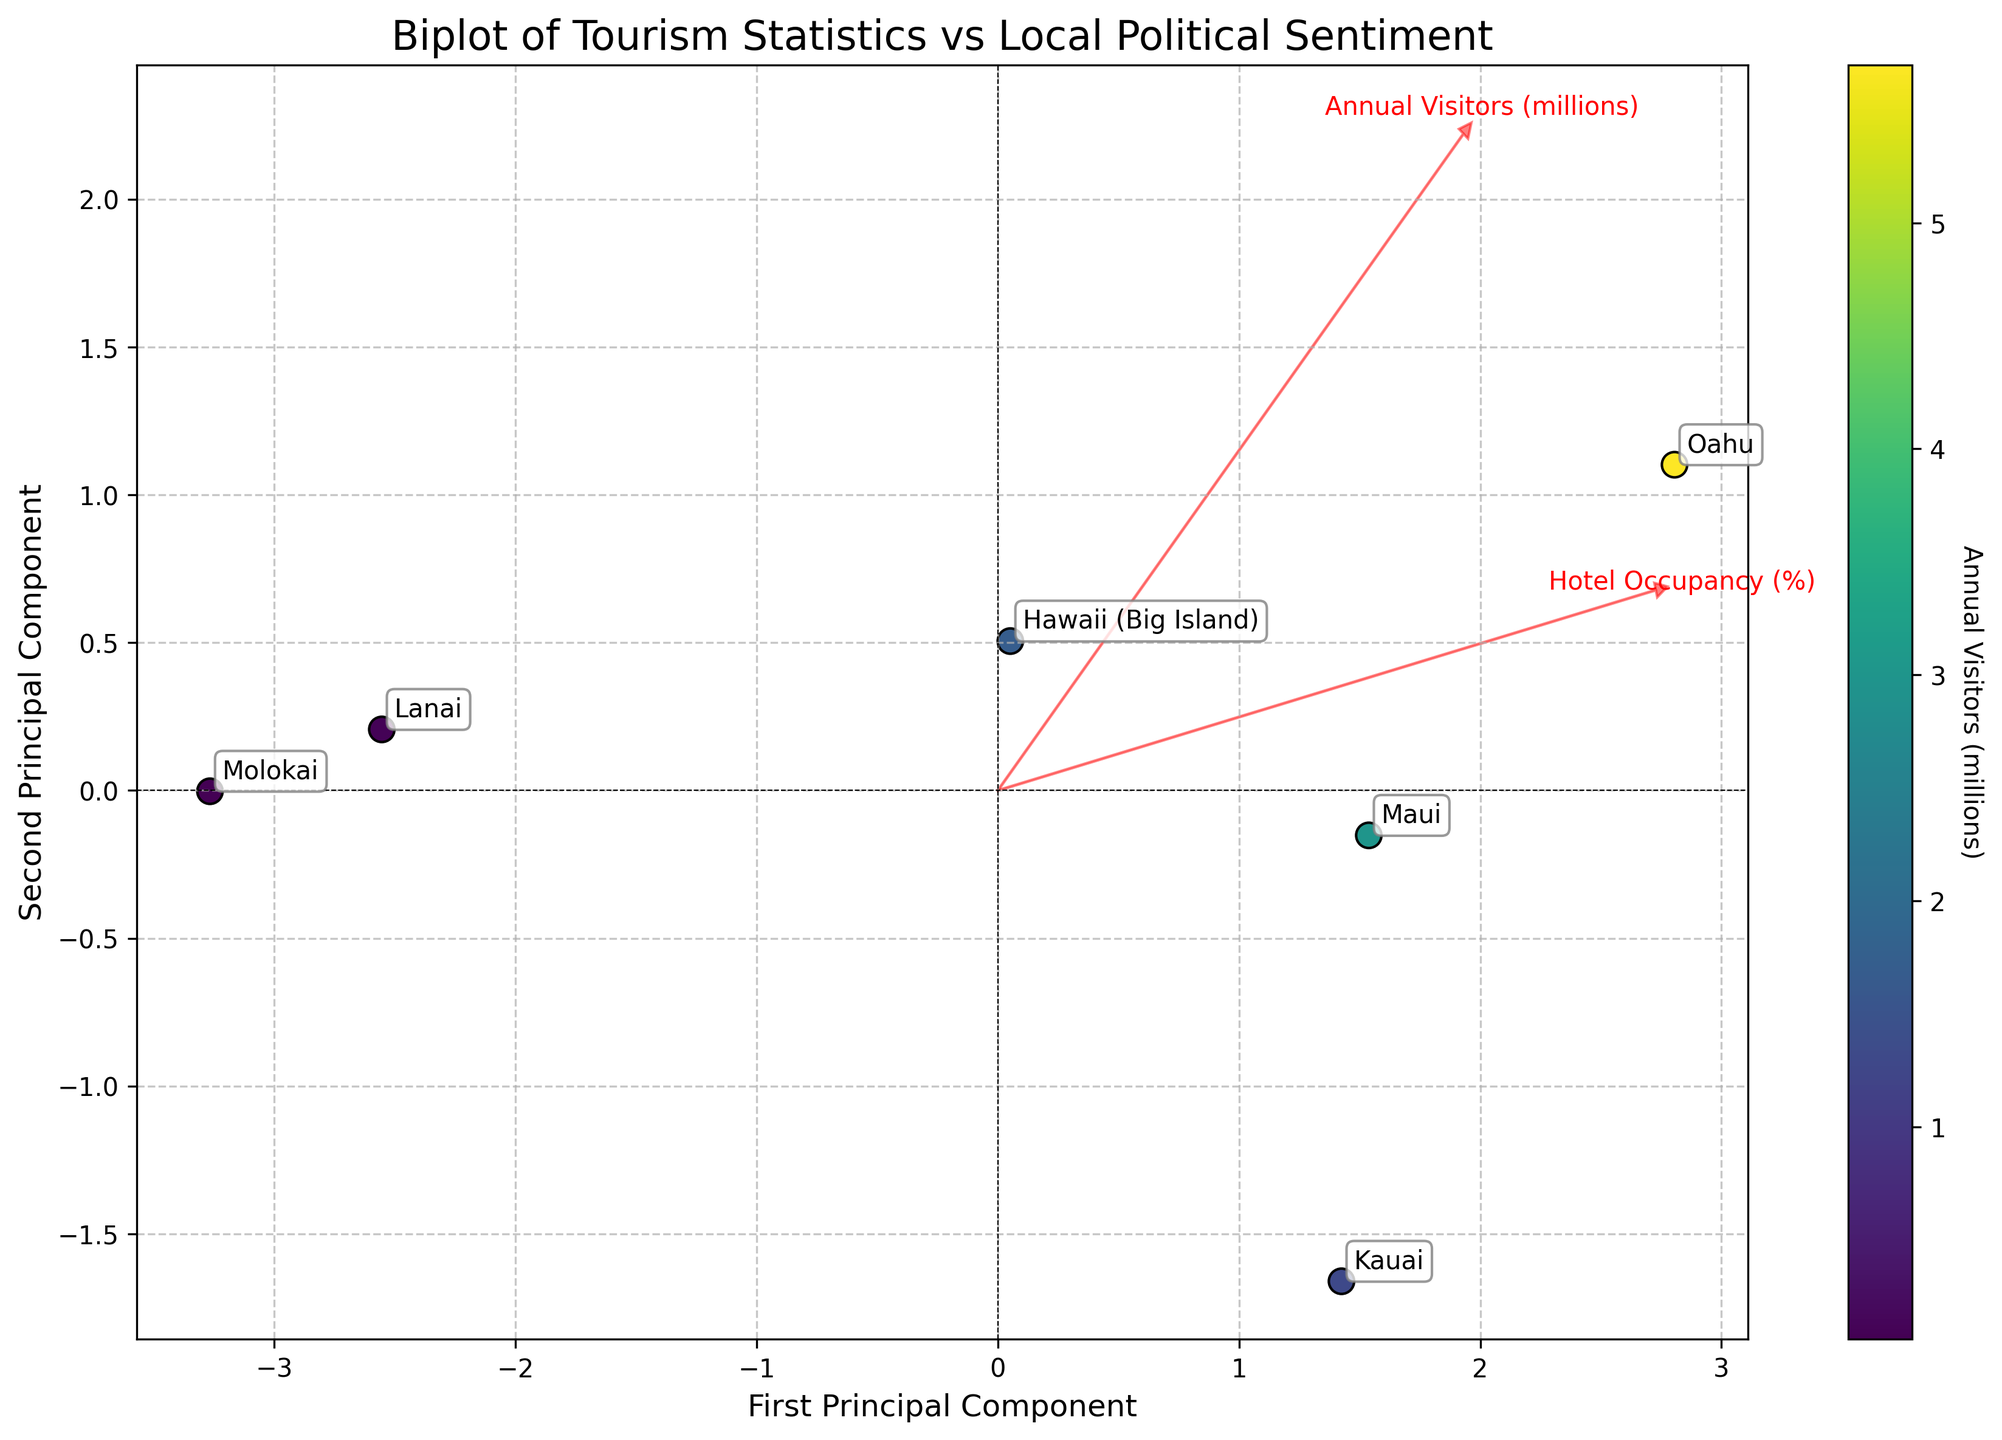How many data points are shown in the biplot? The number of data points is equal to the number of islands represented in the plot. Each island is annotated with its name on the plot, and there are labels for Oahu, Maui, Hawaii (Big Island), Kauai, Lanai, and Molokai.
Answer: 6 Which island has the highest number of annual visitors? The scatter plot uses a color gradient to represent the number of annual visitors, and the plot shows that Oahu has the darkest (and presumably the highest) color intensity among all the islands.
Answer: Oahu How does the hotel occupancy percentage correlate with the first principal component? The figure includes arrows that represent variables. The arrow for ‘Hotel Occupancy (%)’ points right, which aligns with the positive direction of the first principal component on the x-axis. This suggests a positive correlation between hotel occupancy and the first principal component.
Answer: Positive correlation Which islands are close to each other in terms of local approval of tourism and voter turnout? By observing the scatterplot points and their proximity, Molokai and Lanai are located close to each other. These islands have similar positions in the plot, implying similar values for local approval of tourism and voter turnout.
Answer: Molokai and Lanai What variable shows the strongest influence on the second principal component? The arrow that is longest in the direction of the second principal component (y-axis) indicates the strongest influence. In this case, the 'Environmental Concerns (1-10)' arrow points almost vertically, showing the strongest influence on the second principal component.
Answer: Environmental Concerns (1-10) Is there a negative correlation between any two variables represented? Yes, if any two arrows point in nearly opposite directions, it indicates a negative correlation. Here, 'Environmental Concerns (1-10)' and 'Support for Tourism Tax (%)' have arrows pointing in opposite directions, indicating a negative correlation.
Answer: Yes Compare the voter turnout percentage between Oahu and Molokai. From the plot annotations, Oahu's voter turnout percentage is lower than Molokai's because Oahu is positioned lower on the plot relative to the y-axis, which suggests voter turnout.
Answer: Oahu has a lower voter turnout than Molokai Which two islands have the highest support for the tourism tax? The color intensity of the island's points doesn't provide this information directly, but the arrows for 'Support for Tourism Tax (%)' can guide us. Kauai and Oahu have annotations positioned near the positive end of the corresponding arrow, indicating they have high levels of support for the tourism tax.
Answer: Kauai and Oahu Identify the island with the highest local approval of tourism. The direction and magnitude of the arrows, specifically the 'Local Approval of Tourism (%)' arrow, can guide this. Lanai is positioned furthest in the direction of the 'Local Approval of Tourism (%)' arrow, indicating the highest value.
Answer: Lanai 